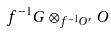<formula> <loc_0><loc_0><loc_500><loc_500>f ^ { - 1 } G \otimes _ { f ^ { - 1 } O ^ { \prime } } O</formula> 